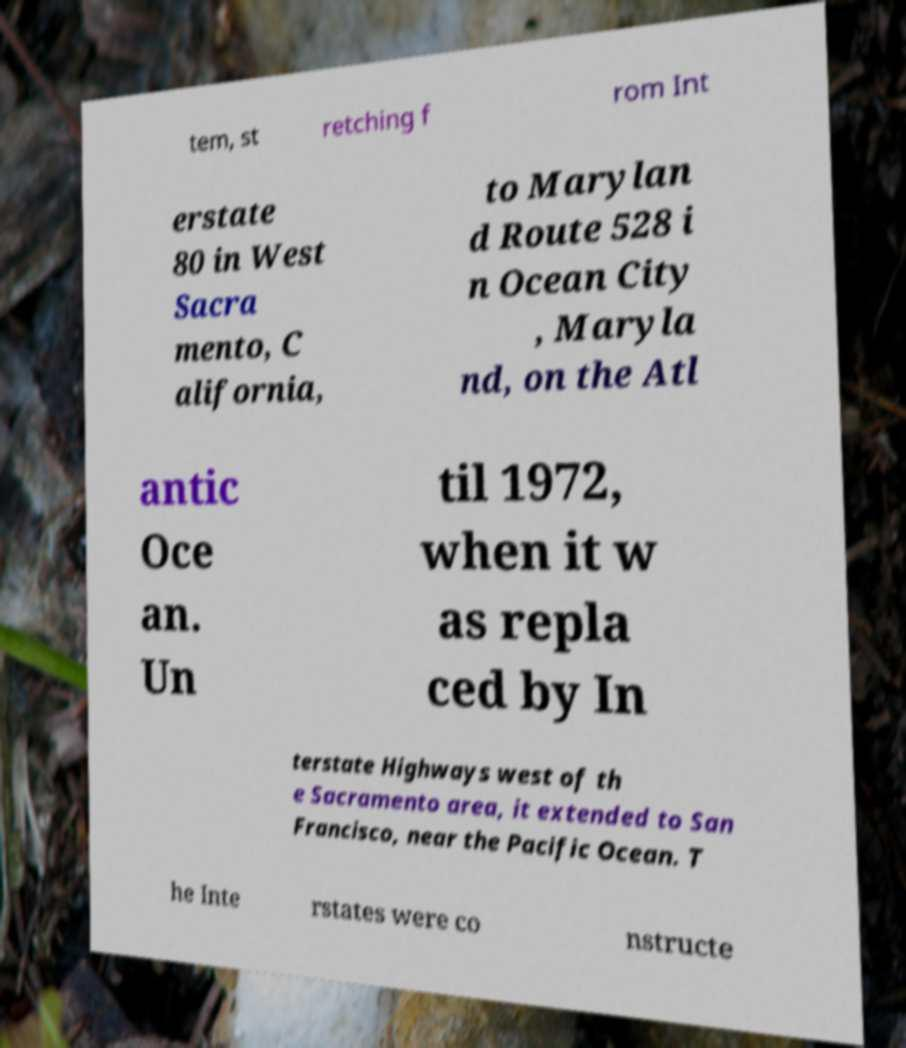For documentation purposes, I need the text within this image transcribed. Could you provide that? tem, st retching f rom Int erstate 80 in West Sacra mento, C alifornia, to Marylan d Route 528 i n Ocean City , Maryla nd, on the Atl antic Oce an. Un til 1972, when it w as repla ced by In terstate Highways west of th e Sacramento area, it extended to San Francisco, near the Pacific Ocean. T he Inte rstates were co nstructe 